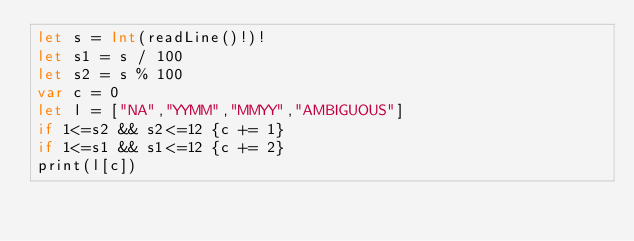Convert code to text. <code><loc_0><loc_0><loc_500><loc_500><_Swift_>let s = Int(readLine()!)!
let s1 = s / 100
let s2 = s % 100
var c = 0
let l = ["NA","YYMM","MMYY","AMBIGUOUS"]
if 1<=s2 && s2<=12 {c += 1}
if 1<=s1 && s1<=12 {c += 2}
print(l[c])</code> 